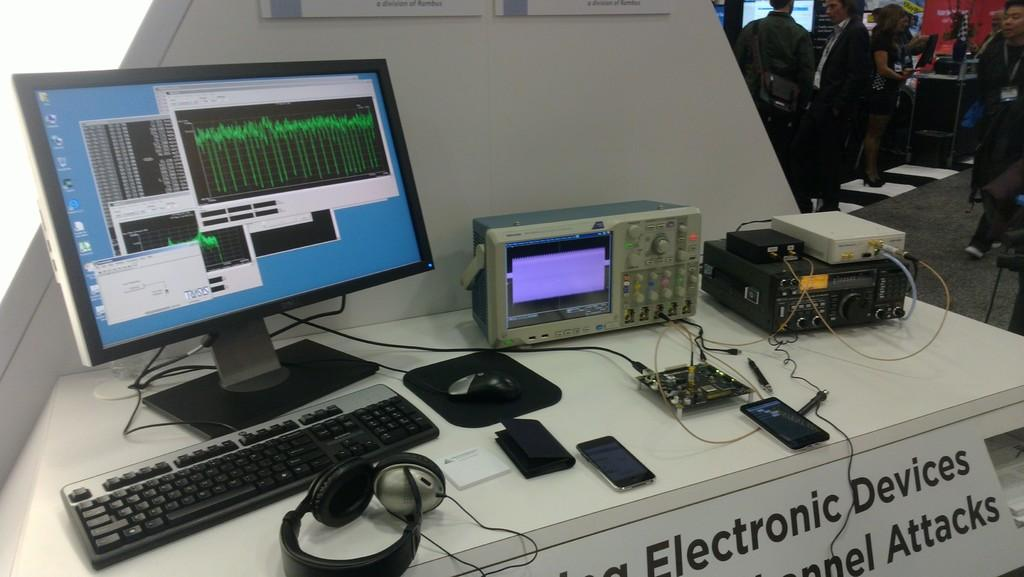<image>
Render a clear and concise summary of the photo. A desk filled with electronic devices with a sign below it with "electronic devices" labelled on it. 